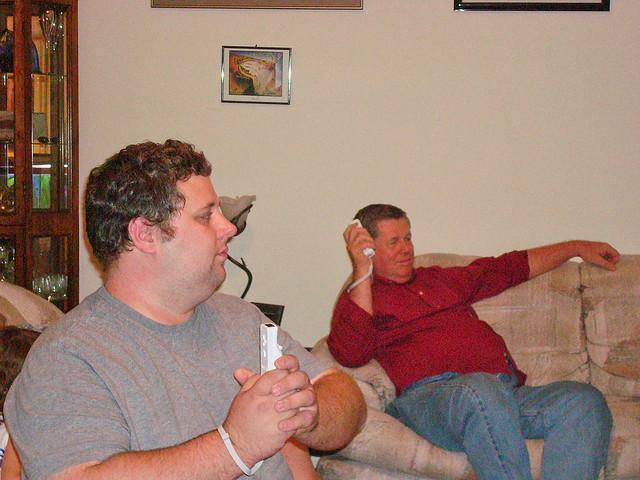What are the two men doing together?
From the following set of four choices, select the accurate answer to respond to the question.
Options: Drawing, singing, playing instruments, gaming. Gaming. 